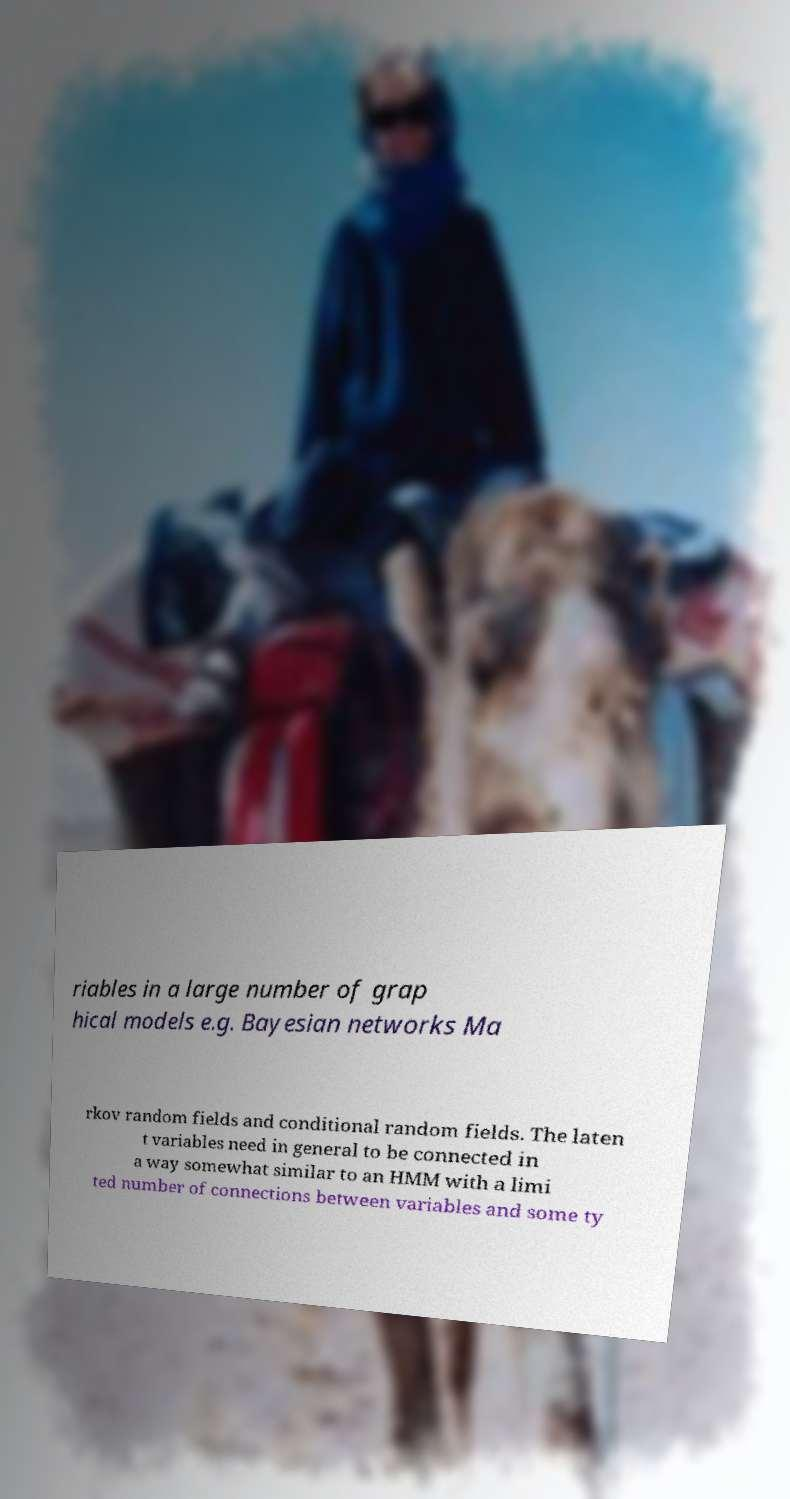What messages or text are displayed in this image? I need them in a readable, typed format. riables in a large number of grap hical models e.g. Bayesian networks Ma rkov random fields and conditional random fields. The laten t variables need in general to be connected in a way somewhat similar to an HMM with a limi ted number of connections between variables and some ty 